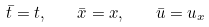<formula> <loc_0><loc_0><loc_500><loc_500>\bar { t } = t , \quad \bar { x } = x , \quad \bar { u } = u _ { x }</formula> 